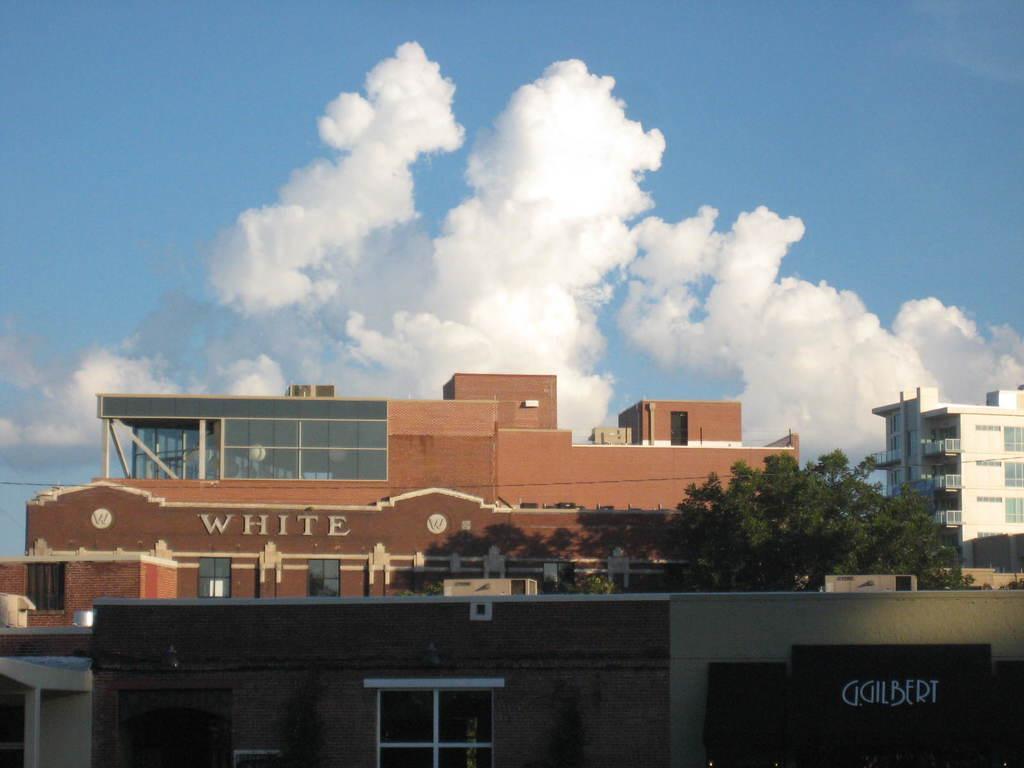Please provide a concise description of this image. In this image there are buildings and there is a tree and on the buildings there is some text written which is visible and the sky is cloudy. 